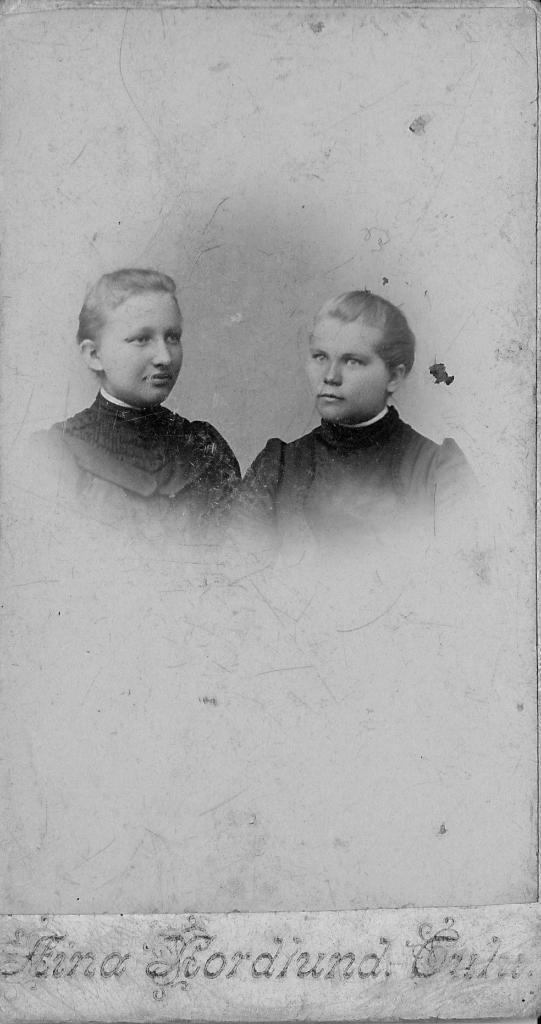In one or two sentences, can you explain what this image depicts? In this image I can see an old photograph in which I can see two persons wearing black and white colored dresses. I can see something is written to the bottom of the image. 